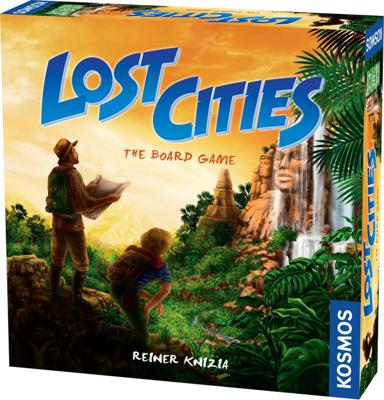What is the name of the board game in the image? The board game shown in the image is titled 'Lost Cities.' It is a well-known adventure and strategy game where players explore mythical cities to score points. 